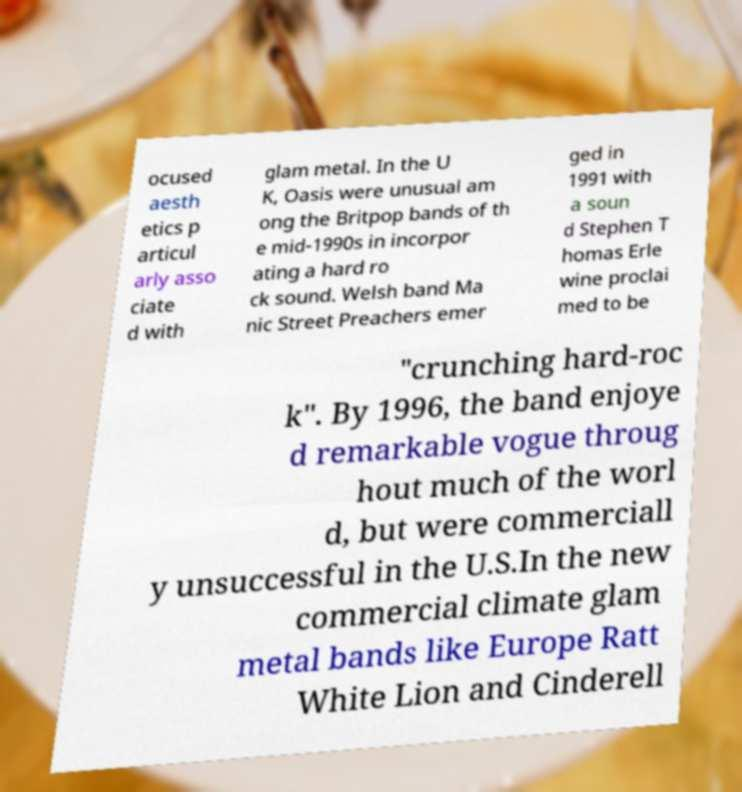I need the written content from this picture converted into text. Can you do that? ocused aesth etics p articul arly asso ciate d with glam metal. In the U K, Oasis were unusual am ong the Britpop bands of th e mid-1990s in incorpor ating a hard ro ck sound. Welsh band Ma nic Street Preachers emer ged in 1991 with a soun d Stephen T homas Erle wine proclai med to be "crunching hard-roc k". By 1996, the band enjoye d remarkable vogue throug hout much of the worl d, but were commerciall y unsuccessful in the U.S.In the new commercial climate glam metal bands like Europe Ratt White Lion and Cinderell 